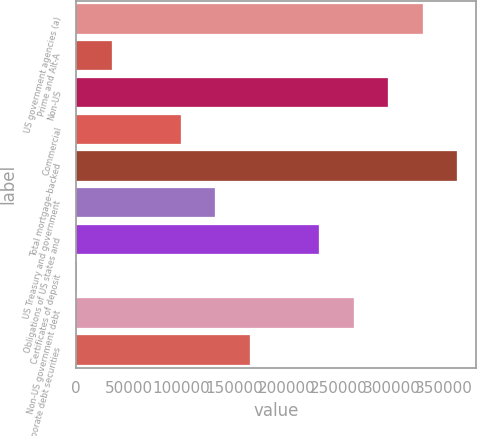Convert chart to OTSL. <chart><loc_0><loc_0><loc_500><loc_500><bar_chart><fcel>US government agencies (a)<fcel>Prime and Alt-A<fcel>Non-US<fcel>Commercial<fcel>Total mortgage-backed<fcel>US Treasury and government<fcel>Obligations of US states and<fcel>Certificates of deposit<fcel>Non-US government debt<fcel>Corporate debt securities<nl><fcel>329977<fcel>33934.6<fcel>297083<fcel>99721.8<fcel>362871<fcel>132615<fcel>231296<fcel>1041<fcel>264190<fcel>165509<nl></chart> 